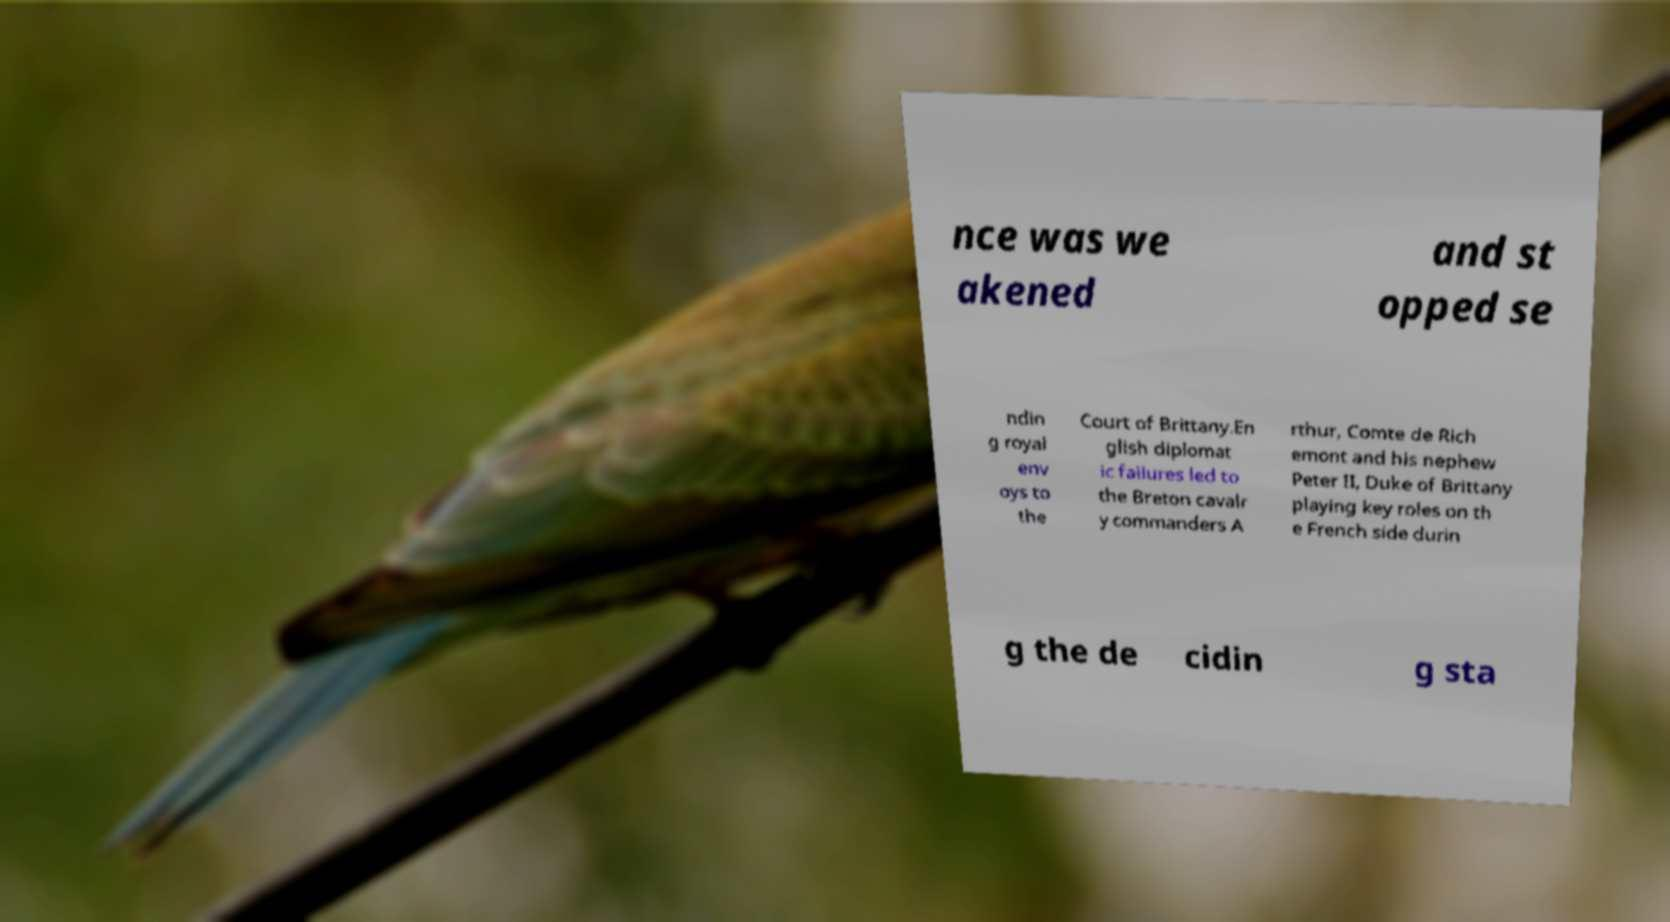For documentation purposes, I need the text within this image transcribed. Could you provide that? nce was we akened and st opped se ndin g royal env oys to the Court of Brittany.En glish diplomat ic failures led to the Breton cavalr y commanders A rthur, Comte de Rich emont and his nephew Peter II, Duke of Brittany playing key roles on th e French side durin g the de cidin g sta 